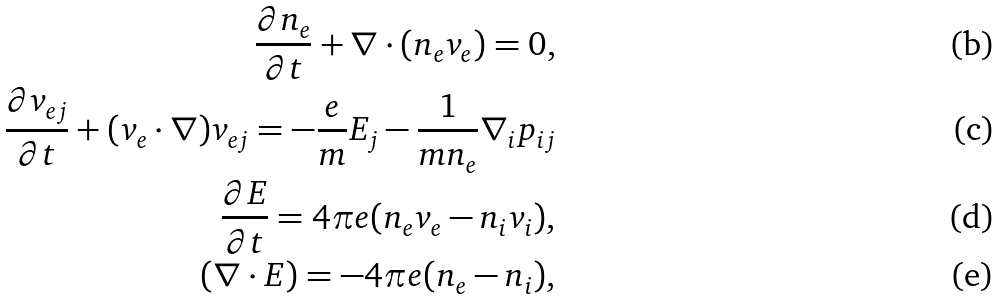<formula> <loc_0><loc_0><loc_500><loc_500>\frac { \partial n _ { e } } { \partial t } + \nabla \cdot ( n _ { e } v _ { e } ) = 0 , \\ \frac { \partial v _ { e j } } { \partial t } + ( v _ { e } \cdot \nabla ) v _ { e j } = - \frac { e } { m } E _ { j } - \frac { 1 } { m n _ { e } } \nabla _ { i } p _ { i j } \\ \frac { \partial E } { \partial t } = 4 \pi e ( n _ { e } v _ { e } - n _ { i } v _ { i } ) , \\ ( \nabla \cdot E ) = - 4 \pi e ( n _ { e } - n _ { i } ) ,</formula> 